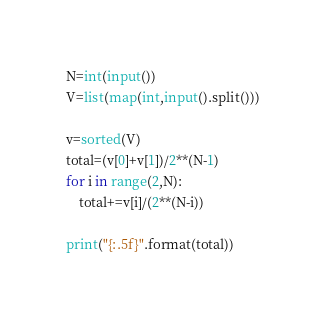Convert code to text. <code><loc_0><loc_0><loc_500><loc_500><_Python_>N=int(input())
V=list(map(int,input().split()))

v=sorted(V)
total=(v[0]+v[1])/2**(N-1)
for i in range(2,N):
    total+=v[i]/(2**(N-i))

print("{:.5f}".format(total))</code> 